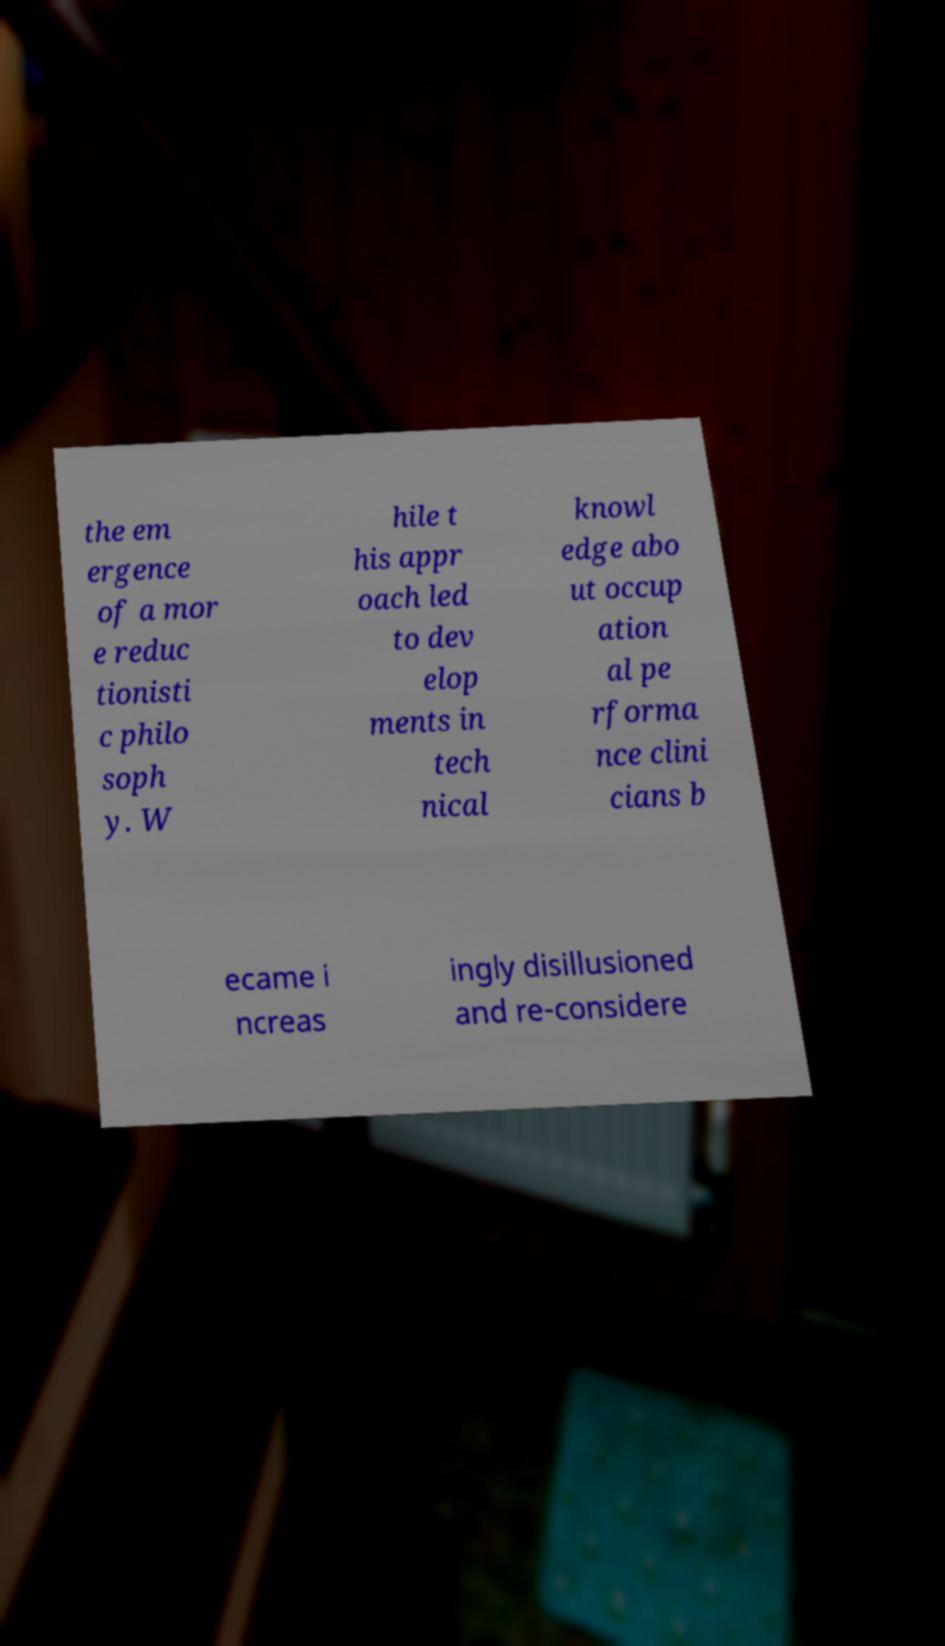Please read and relay the text visible in this image. What does it say? the em ergence of a mor e reduc tionisti c philo soph y. W hile t his appr oach led to dev elop ments in tech nical knowl edge abo ut occup ation al pe rforma nce clini cians b ecame i ncreas ingly disillusioned and re-considere 